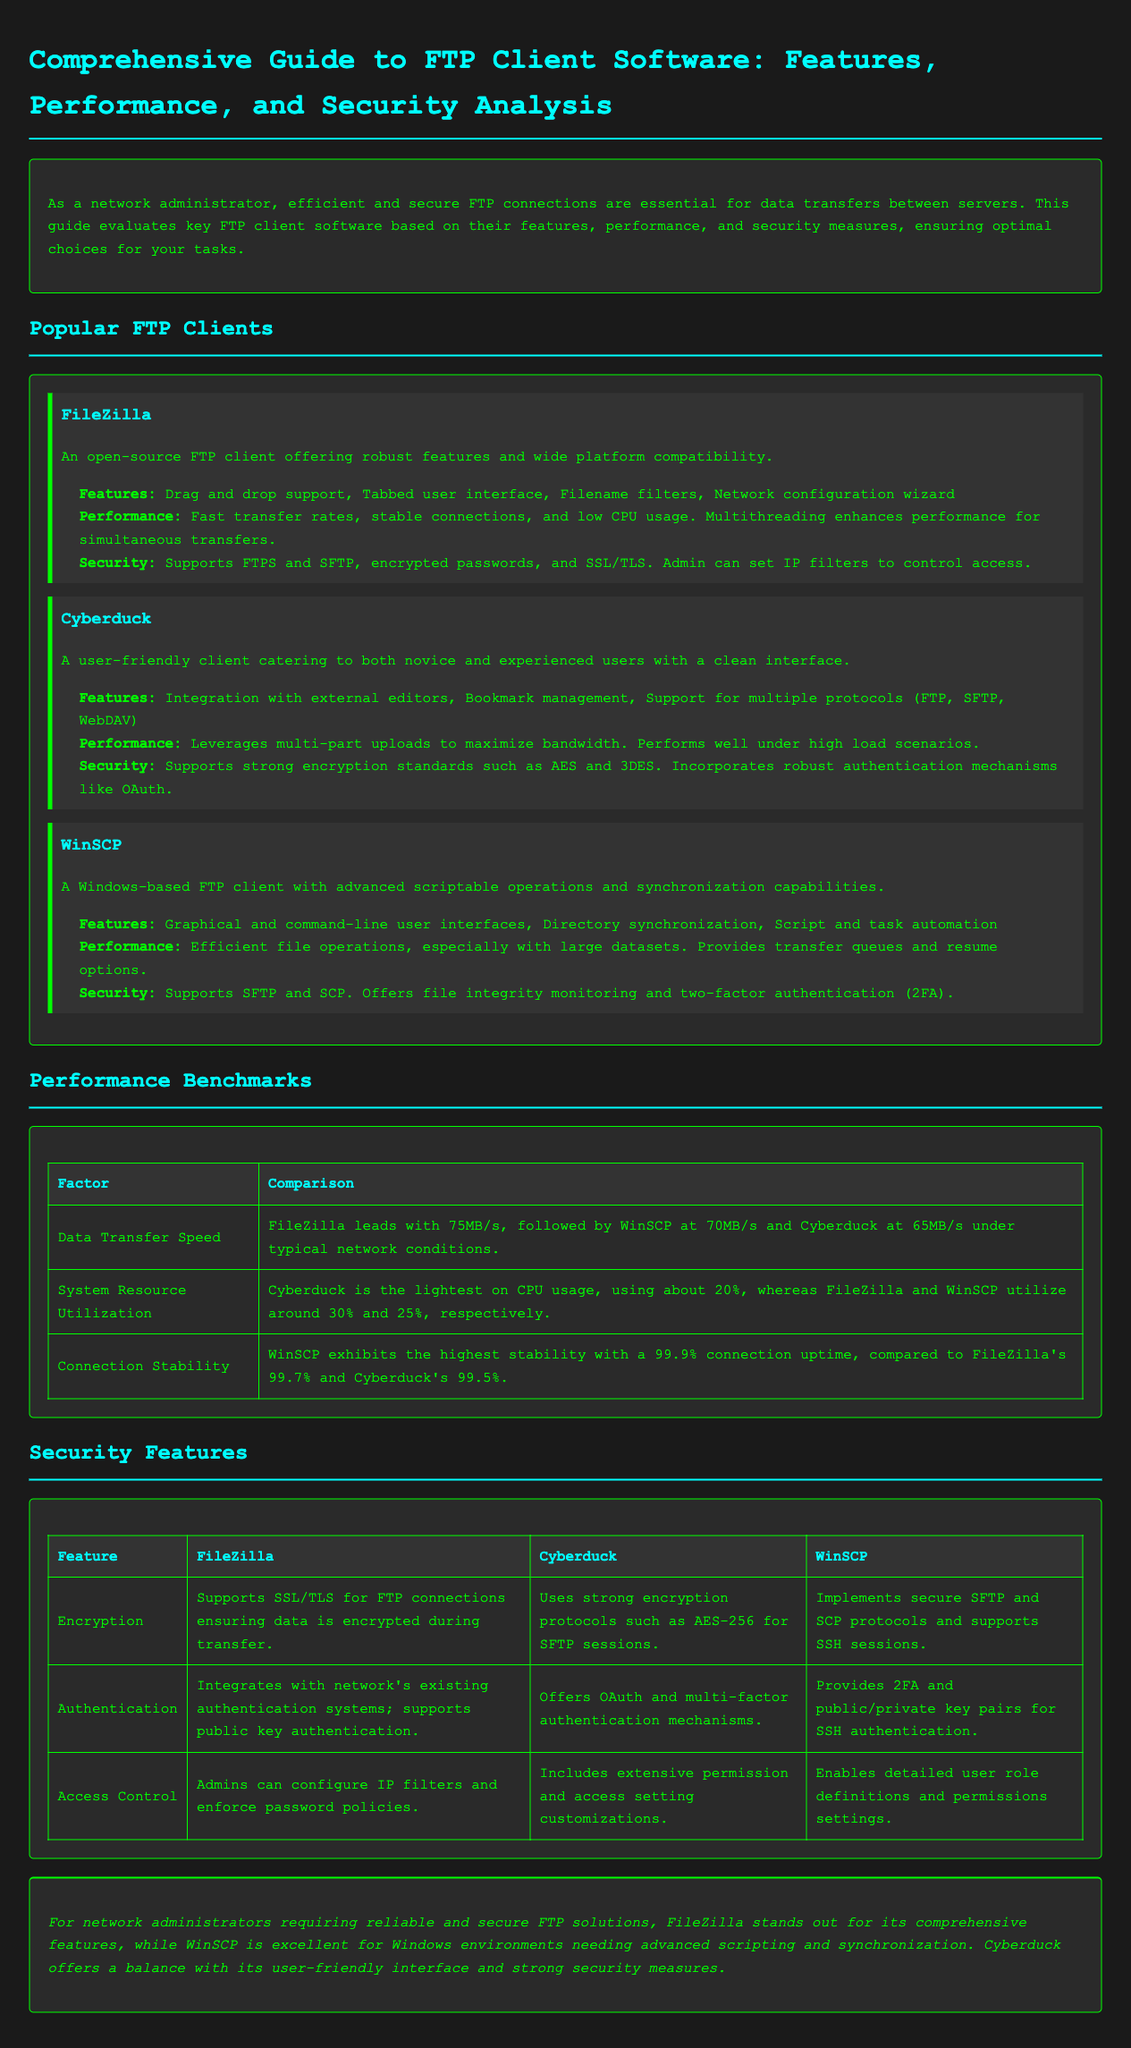What is the name of the first FTP client mentioned? The first FTP client mentioned in the document is FileZilla.
Answer: FileZilla Which FTP client is user-friendly for both novice and experienced users? Cyberduck is described as user-friendly for both categories of users.
Answer: Cyberduck What is the maximum data transfer speed of FileZilla? FileZilla leads with a transfer speed of 75MB/s as noted in the performance benchmarks.
Answer: 75MB/s How many protocols does Cyberduck support? Cyberduck supports multiple protocols including FTP, SFTP, and WebDAV as stated in the features section.
Answer: Multiple protocols What is the connection stability percentage of WinSCP? WinSCP exhibits a connection stability of 99.9%, highlighted as the highest in the document.
Answer: 99.9% Which encryption standard does Cyberduck use for SFTP sessions? The document states that Cyberduck uses AES-256 encryption for SFTP sessions.
Answer: AES-256 What feature allows FileZilla to control access? FileZilla allows admins to set IP filters to control access, as mentioned under its security section.
Answer: IP filters Which FTP client provides two-factor authentication? WinSCP offers two-factor authentication as part of its security features.
Answer: WinSCP What is the conclusion for network administrators seeking FTP solutions? The conclusion emphasizes that FileZilla stands out for features, and WinSCP is excellent for scripting and synchronization.
Answer: FileZilla and WinSCP 